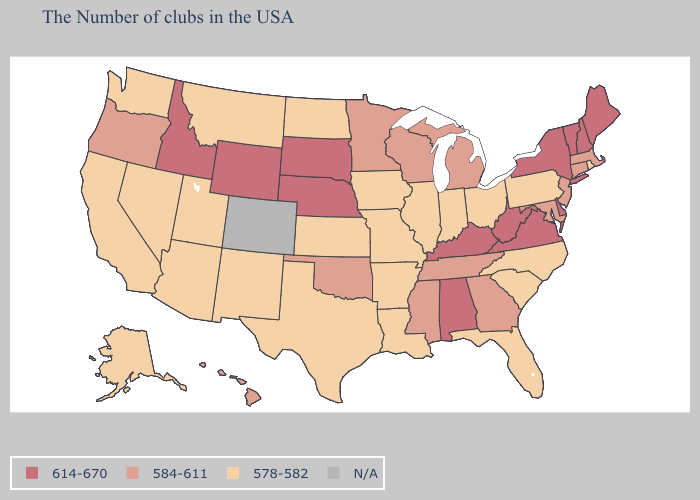How many symbols are there in the legend?
Write a very short answer. 4. What is the lowest value in the Northeast?
Answer briefly. 578-582. Does Wyoming have the highest value in the USA?
Write a very short answer. Yes. Among the states that border North Dakota , which have the lowest value?
Short answer required. Montana. What is the value of South Dakota?
Quick response, please. 614-670. Name the states that have a value in the range N/A?
Short answer required. Colorado. Does Missouri have the highest value in the MidWest?
Write a very short answer. No. Does Vermont have the highest value in the USA?
Quick response, please. Yes. Among the states that border Vermont , does New Hampshire have the highest value?
Answer briefly. Yes. Name the states that have a value in the range 584-611?
Concise answer only. Massachusetts, Connecticut, New Jersey, Maryland, Georgia, Michigan, Tennessee, Wisconsin, Mississippi, Minnesota, Oklahoma, Oregon, Hawaii. What is the value of Kansas?
Keep it brief. 578-582. What is the value of Alabama?
Be succinct. 614-670. Name the states that have a value in the range N/A?
Be succinct. Colorado. Which states hav the highest value in the MidWest?
Be succinct. Nebraska, South Dakota. 